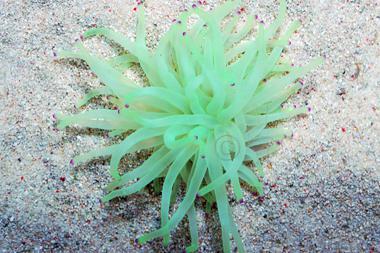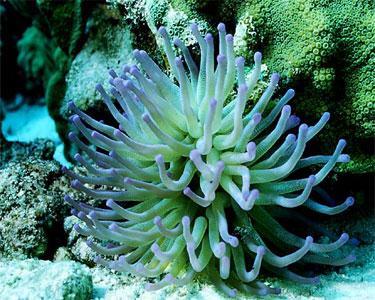The first image is the image on the left, the second image is the image on the right. Evaluate the accuracy of this statement regarding the images: "Striped clownfish are swimming in one image of an anemone.". Is it true? Answer yes or no. No. The first image is the image on the left, the second image is the image on the right. Evaluate the accuracy of this statement regarding the images: "At least one of the images contains an orange and white fish.". Is it true? Answer yes or no. No. 